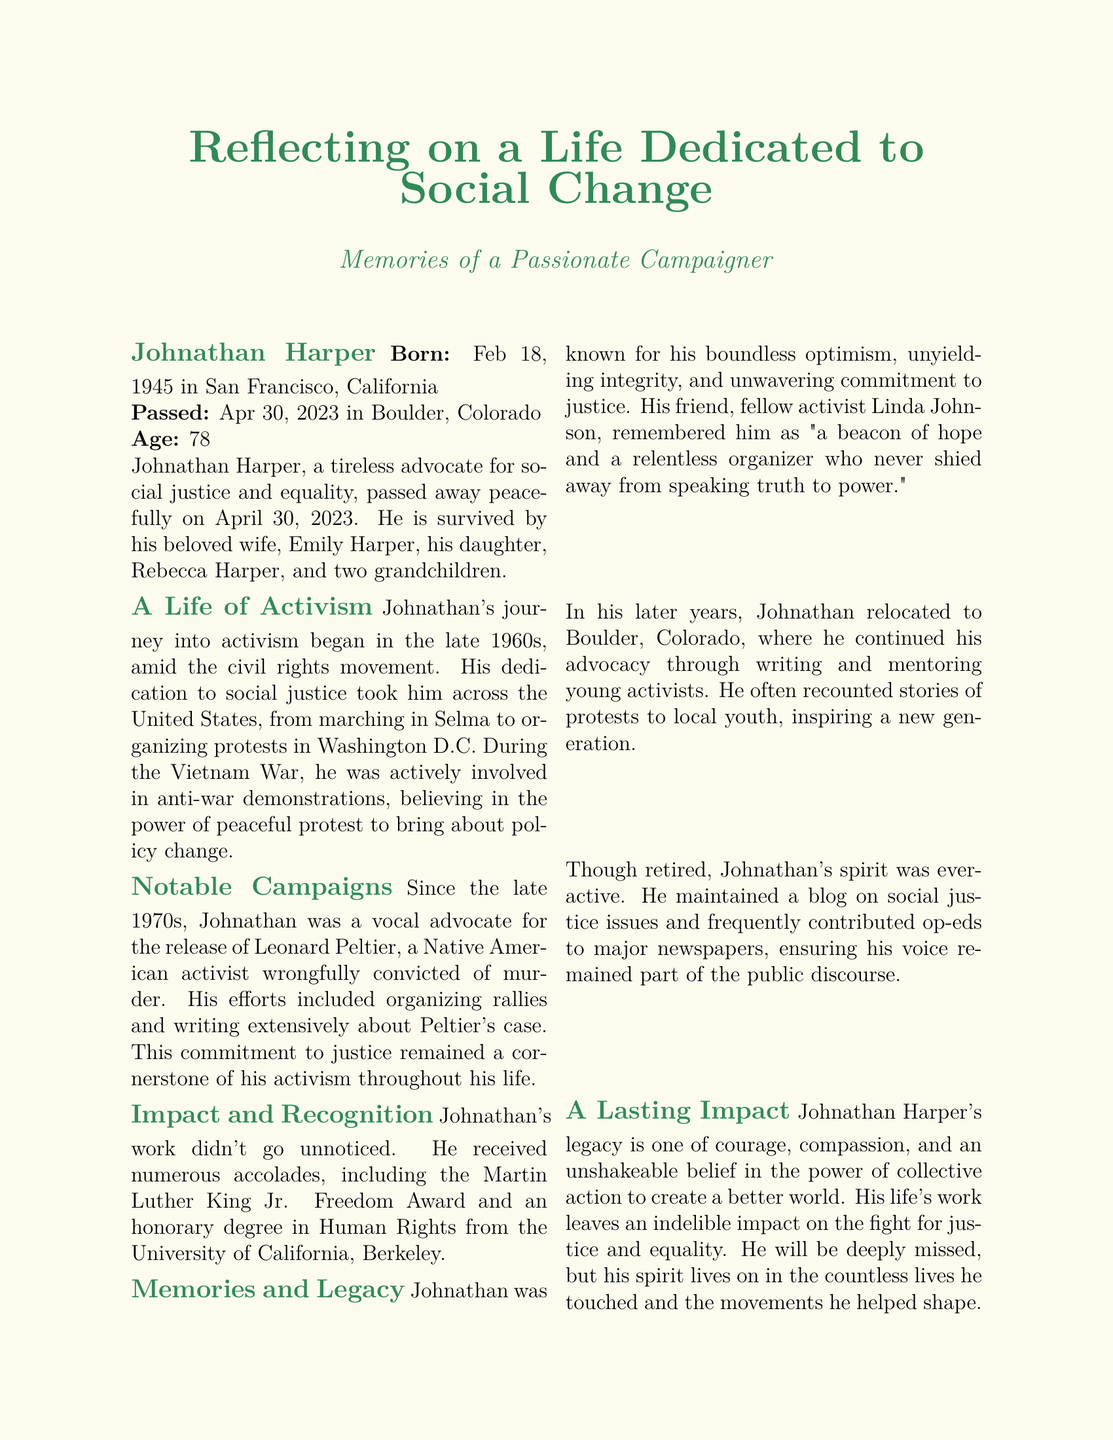What is Johnathan Harper's date of birth? The document states that Johnathan Harper was born on February 18, 1945.
Answer: February 18, 1945 Where did Johnathan Harper pass away? According to the document, he passed away in Boulder, Colorado.
Answer: Boulder, Colorado What award did Johnathan receive for his activism? The document mentions that he received the Martin Luther King Jr. Freedom Award.
Answer: Martin Luther King Jr. Freedom Award What was a notable focus of Johnathan's activism? The document specifies that he was a vocal advocate for the release of Leonard Peltier.
Answer: Leonard Peltier In what year did Johnathan Harper die? The obituary states that he passed away on April 30, 2023.
Answer: 2023 Who survived Johnathan Harper? The document lists his wife, Emily Harper, daughter, Rebecca Harper, and two grandchildren as survivors.
Answer: Emily Harper, Rebecca Harper, two grandchildren What did Johnathan do in his later years? According to the document, he continued his advocacy through writing and mentoring young activists.
Answer: Writing and mentoring How old was Johnathan Harper at the time of his passing? The document specifies that Johnathan was 78 years old.
Answer: 78 What type of social issues did Johnathan maintain a blog about? The document indicates that he maintained a blog on social justice issues.
Answer: Social justice issues 